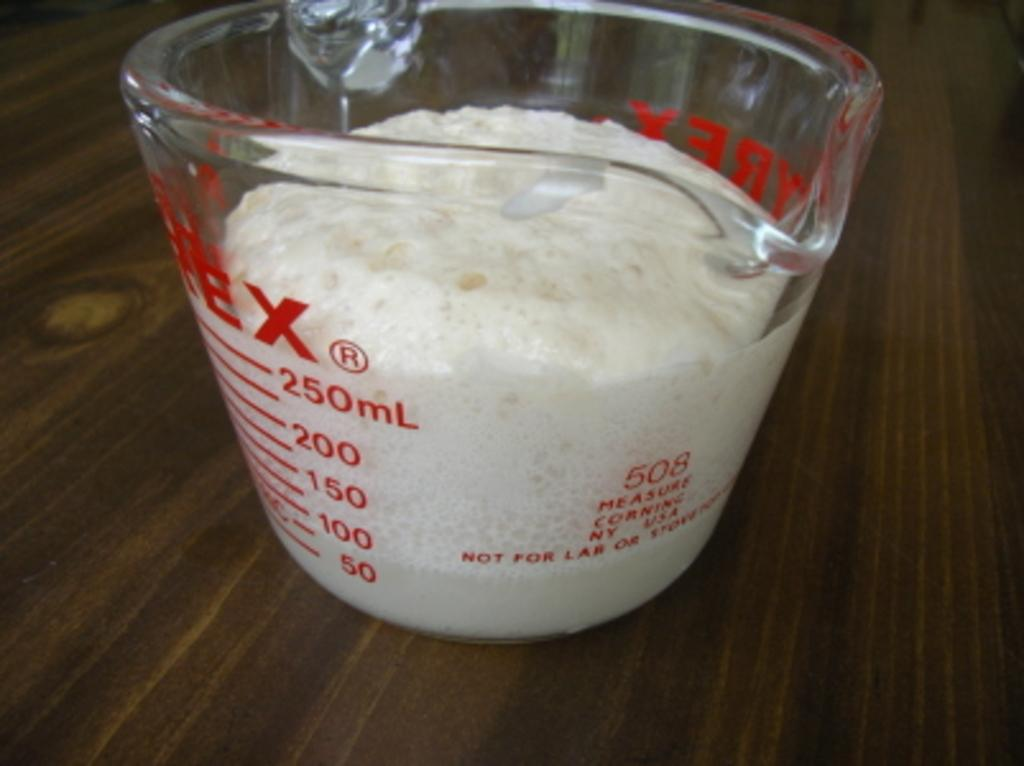What piece of furniture is present in the image? There is a table in the image. What is placed on the table? There is a bowl on the table. What type of slave is depicted in the image? There is no slave depicted in the image; it only features a table and a bowl. What is the weather like in the image? The image does not provide any information about the weather. 